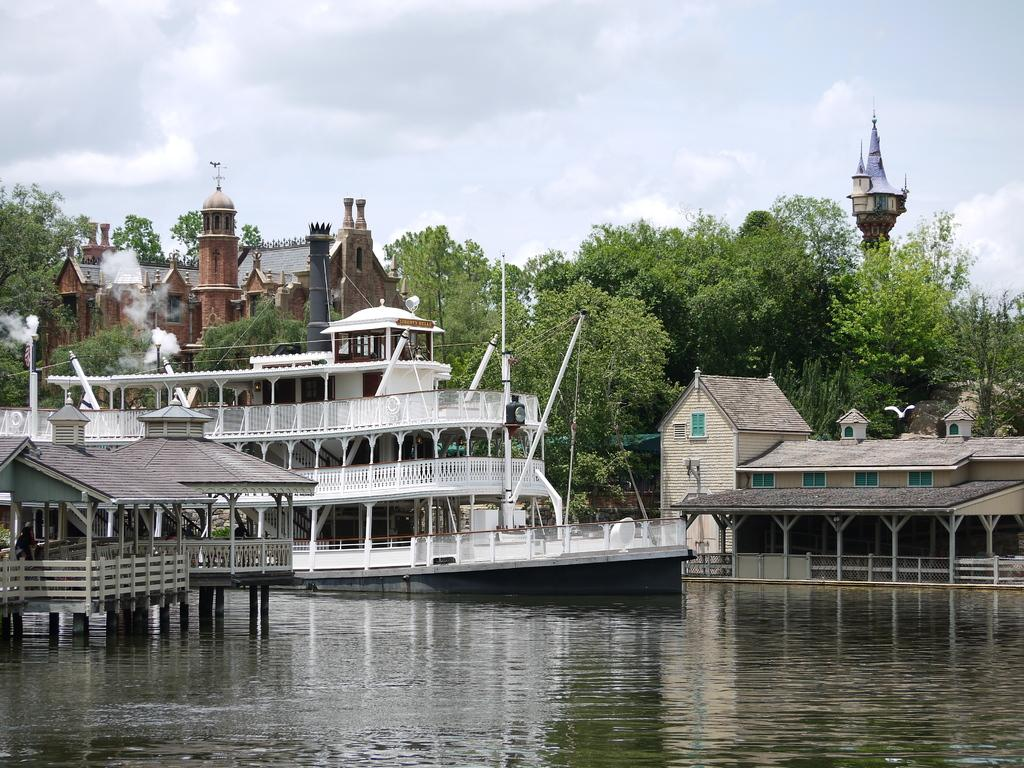What is the main subject of the image? The main subject of the image is a ship. What else can be seen in the image besides the ship? There are buildings, trees, water, and the sky visible in the image. Can you describe the setting of the image? The image appears to be set near a body of water, with buildings and trees in the background. What type of ink is being used to write the story on the ship's sail? There is no story or ink present on the ship's sail in the image. How many girls are visible on the ship in the image? There are no girls visible on the ship in the image. 